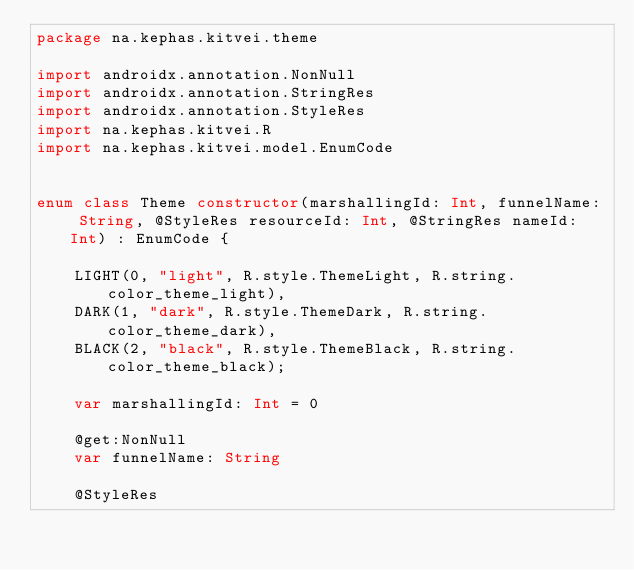Convert code to text. <code><loc_0><loc_0><loc_500><loc_500><_Kotlin_>package na.kephas.kitvei.theme

import androidx.annotation.NonNull
import androidx.annotation.StringRes
import androidx.annotation.StyleRes
import na.kephas.kitvei.R
import na.kephas.kitvei.model.EnumCode


enum class Theme constructor(marshallingId: Int, funnelName: String, @StyleRes resourceId: Int, @StringRes nameId: Int) : EnumCode {

    LIGHT(0, "light", R.style.ThemeLight, R.string.color_theme_light),
    DARK(1, "dark", R.style.ThemeDark, R.string.color_theme_dark),
    BLACK(2, "black", R.style.ThemeBlack, R.string.color_theme_black);

    var marshallingId: Int = 0

    @get:NonNull
    var funnelName: String

    @StyleRes</code> 